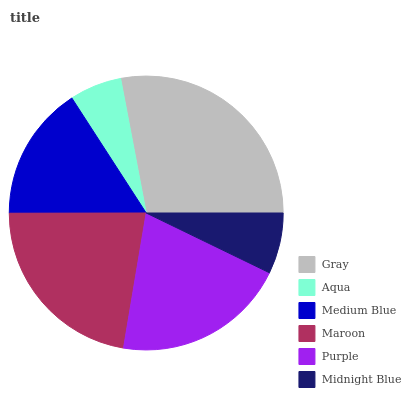Is Aqua the minimum?
Answer yes or no. Yes. Is Gray the maximum?
Answer yes or no. Yes. Is Medium Blue the minimum?
Answer yes or no. No. Is Medium Blue the maximum?
Answer yes or no. No. Is Medium Blue greater than Aqua?
Answer yes or no. Yes. Is Aqua less than Medium Blue?
Answer yes or no. Yes. Is Aqua greater than Medium Blue?
Answer yes or no. No. Is Medium Blue less than Aqua?
Answer yes or no. No. Is Purple the high median?
Answer yes or no. Yes. Is Medium Blue the low median?
Answer yes or no. Yes. Is Aqua the high median?
Answer yes or no. No. Is Purple the low median?
Answer yes or no. No. 